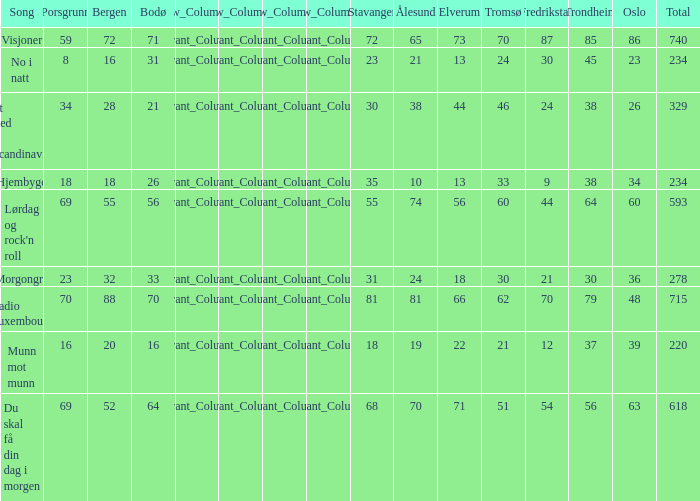When bergen is 88, what is the alesund? 81.0. 